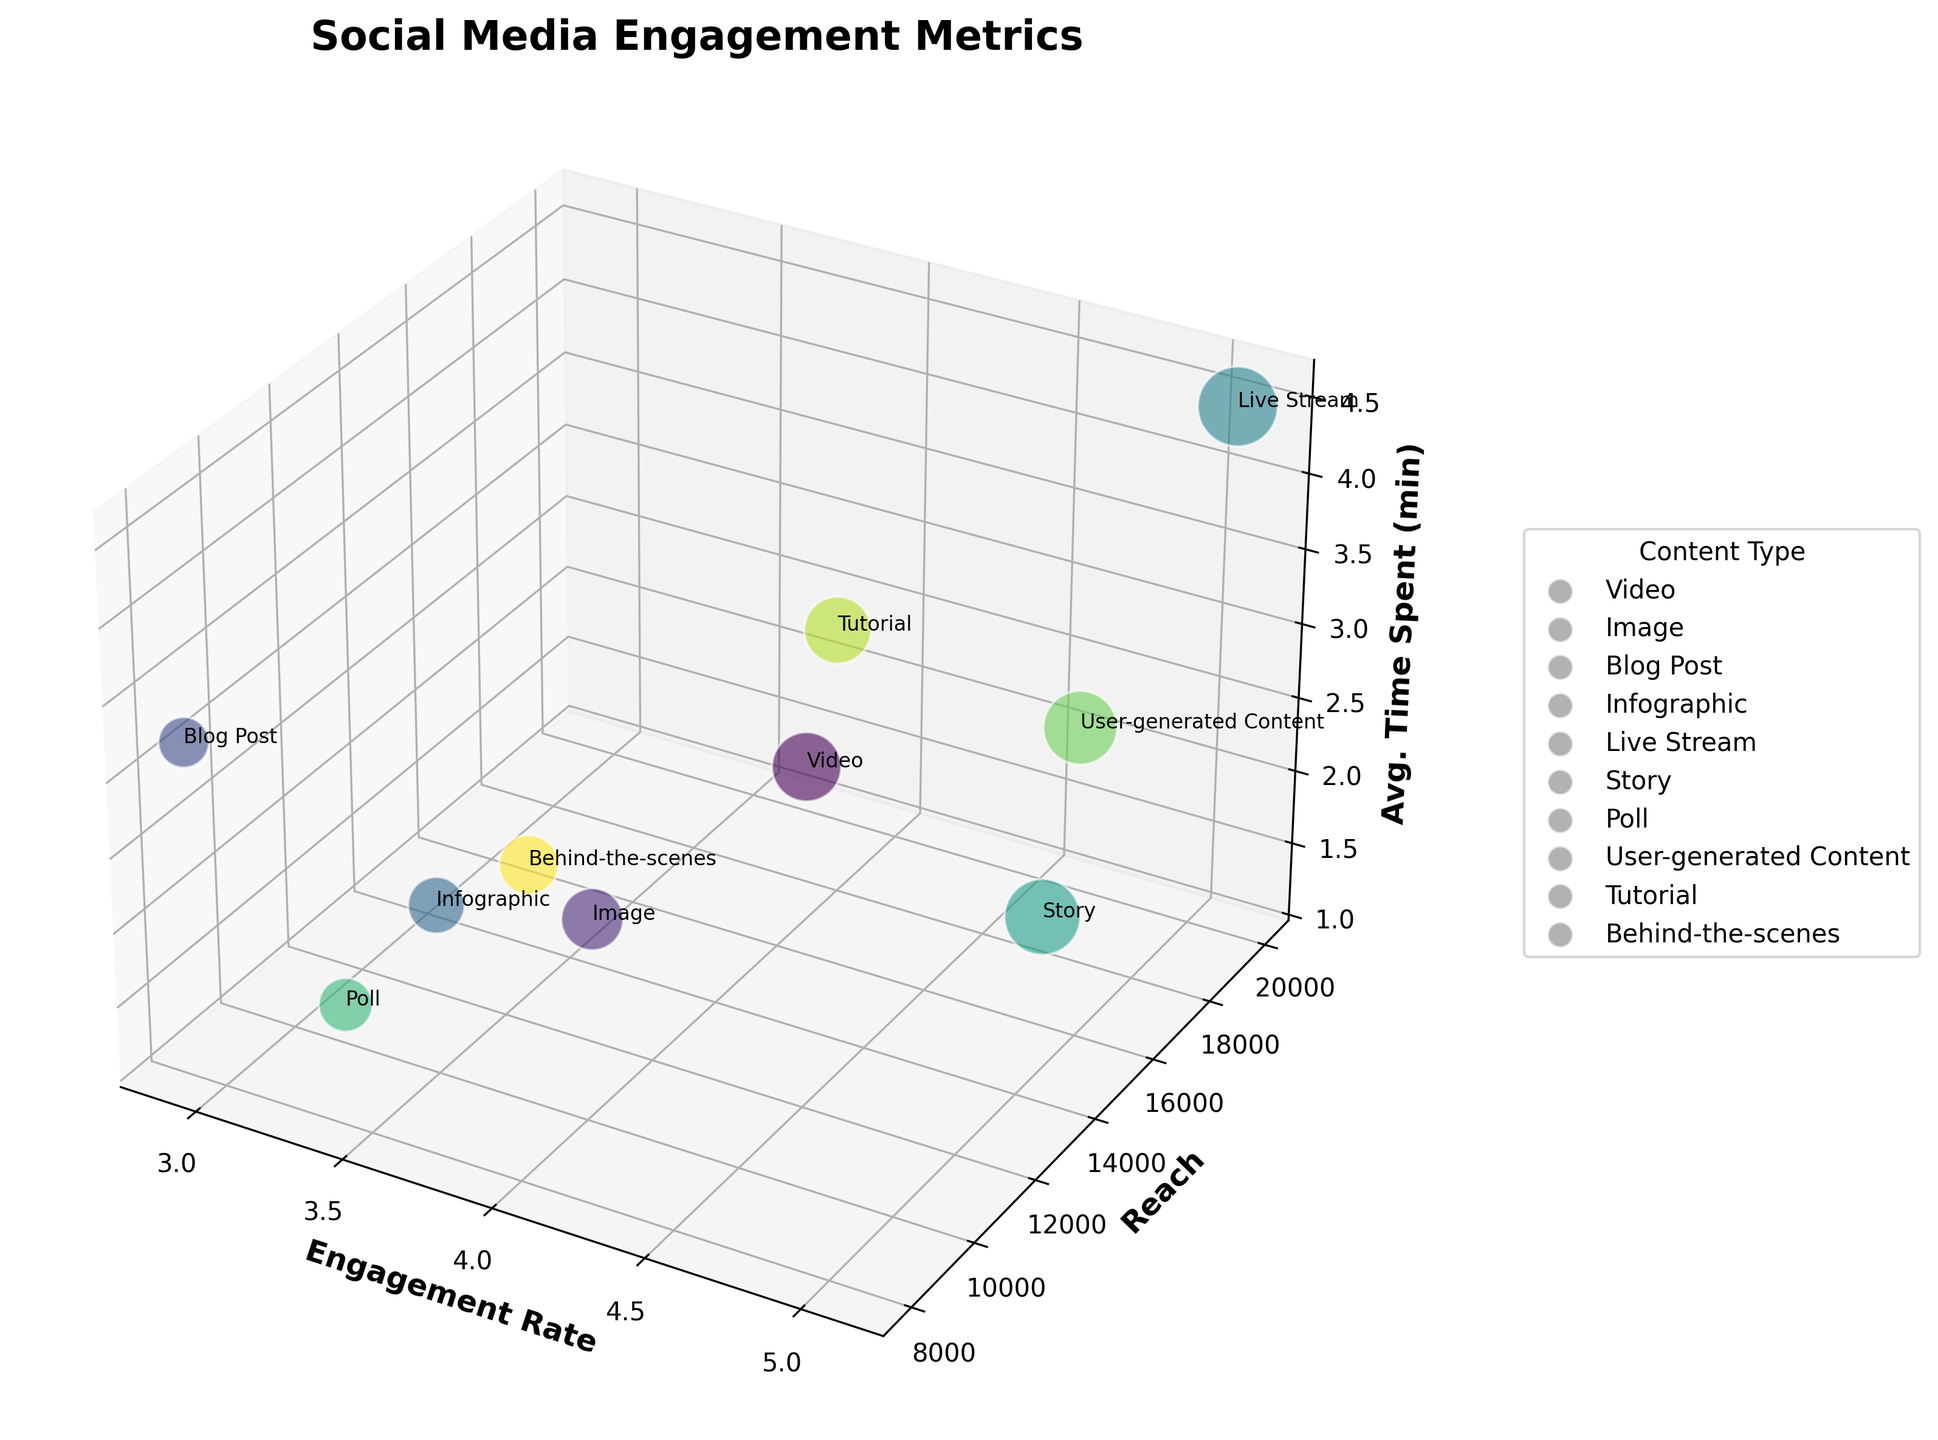How many content types are displayed in the chart? Count the unique content types labeled on the chart.
Answer: 10 What is the title of the figure? Read the title text displayed at the top of the figure.
Answer: Social Media Engagement Metrics What axis represents the 'Engagement Rate'? Identify the axis labeled as 'Engagement Rate'. In a 3D plot, 'Engagement Rate' will be labeled on either the x, y, or z axis.
Answer: X-axis Which content type has the highest engagement rate? Observe the points on the X-axis (Engagement Rate) and identify the highest value. Then check the label attached to this point.
Answer: Live Stream Compare the engagement rates of 'Video' and 'Story'. Which one is higher? Locate the points for 'Video' and 'Story' on the X-axis. Note their engagement rates and compare them.
Answer: Story For the 'Live Stream' content, what is the average time spent? Locate the 'Live Stream' label on the chart and observe its position on the Z-axis (Avg. Time Spent).
Answer: 4.5 minutes What content type has the smallest reach? Observe the points on the Y-axis (Reach) and identify the lowest value. Then check the label attached to this point.
Answer: Blog Post What is the combined reach of 'Video' and 'User-generated Content'? Locate the points for 'Video' and 'User-generated Content' on the Y-axis (Reach), note their values and sum them up: 15000 + 17000.
Answer: 32000 Which content types target the audience aged 18-24? Note the content types in the legend and labels targeting the 18-24 audience group.
Answer: Video, Live Stream, User-generated Content Between 'Tutorial' and 'Poll', which had a higher average time spent by the audience? Compare the Z-axis values for 'Tutorial' and 'Poll'. Note which one is higher.
Answer: Tutorial 